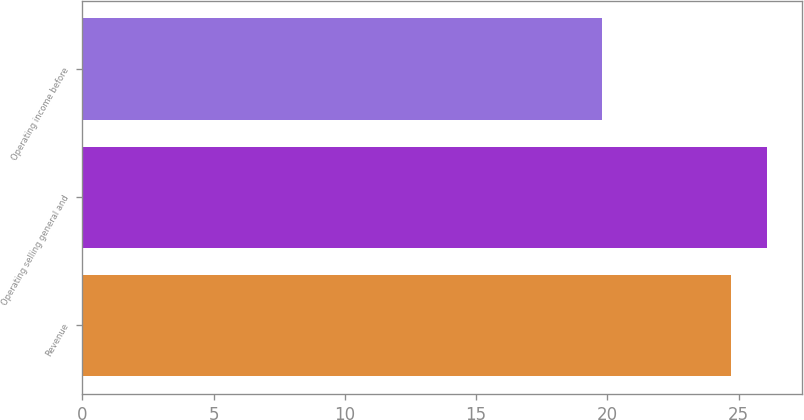<chart> <loc_0><loc_0><loc_500><loc_500><bar_chart><fcel>Revenue<fcel>Operating selling general and<fcel>Operating income before<nl><fcel>24.7<fcel>26.1<fcel>19.8<nl></chart> 